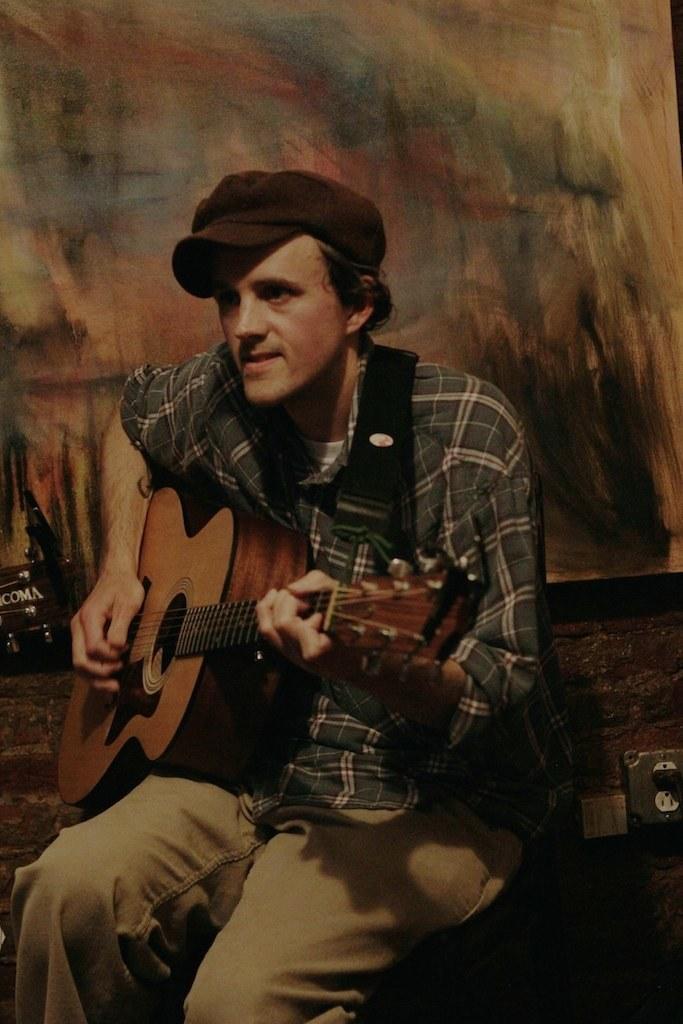Could you give a brief overview of what you see in this image? In the middle there is a man sitting on the bench ,he is playing guitar and holding it. he is wearing a shirt, trouser and hat. To the right there is a bag. 